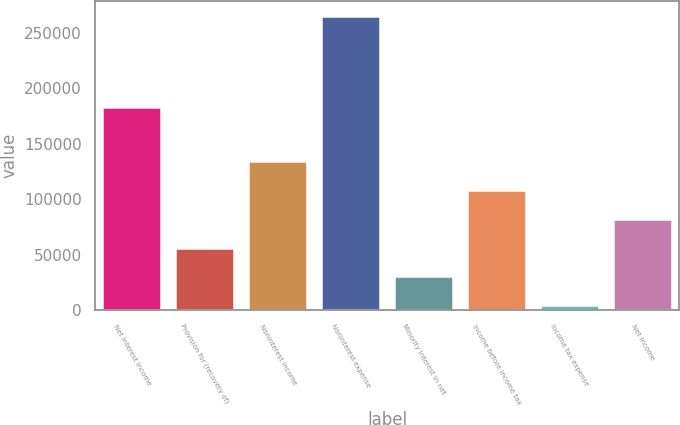Convert chart. <chart><loc_0><loc_0><loc_500><loc_500><bar_chart><fcel>Net interest income<fcel>Provision for (recovery of)<fcel>Noninterest income<fcel>Noninterest expense<fcel>Minority interest in net<fcel>Income before income tax<fcel>Income tax expense<fcel>Net income<nl><fcel>183138<fcel>56318.4<fcel>134535<fcel>264896<fcel>30246.2<fcel>108463<fcel>4174<fcel>82390.6<nl></chart> 